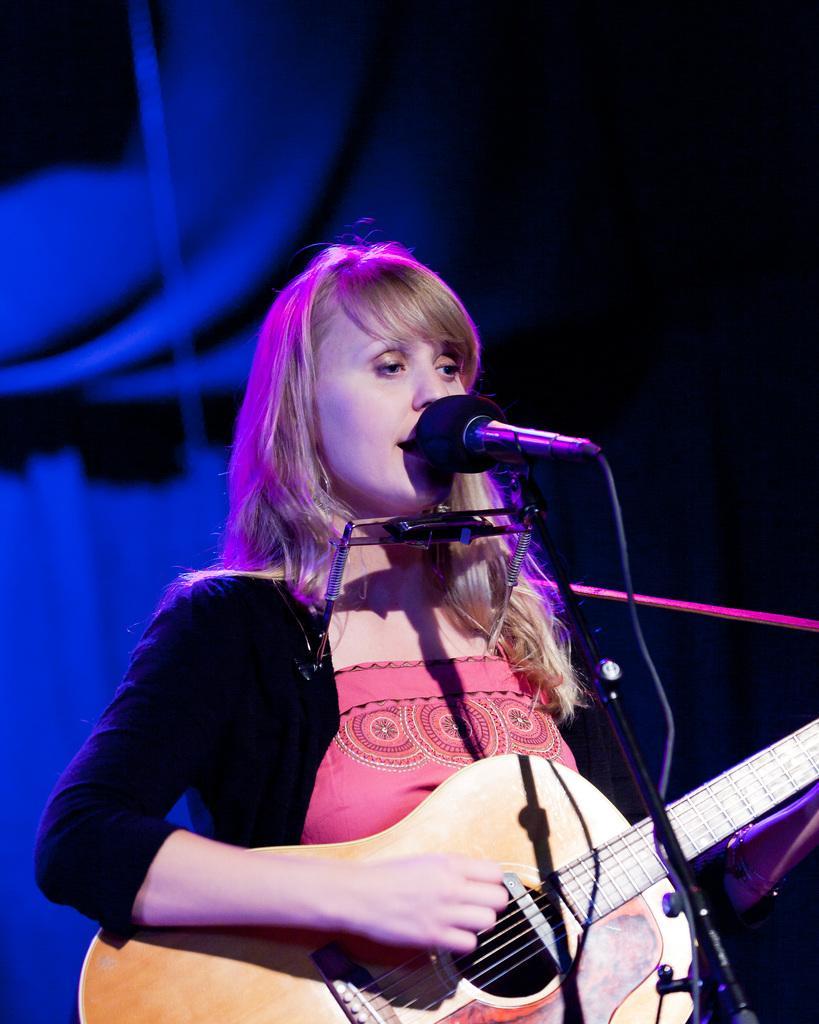How would you summarize this image in a sentence or two? In this image there is one woman who is standing and she is holding a guitar in front of her there is one mike it seems that she is singing. 